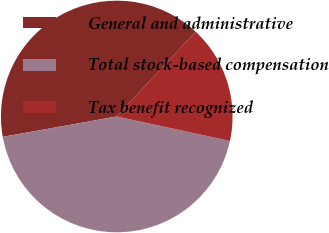Convert chart to OTSL. <chart><loc_0><loc_0><loc_500><loc_500><pie_chart><fcel>General and administrative<fcel>Total stock-based compensation<fcel>Tax benefit recognized<nl><fcel>39.73%<fcel>43.8%<fcel>16.47%<nl></chart> 